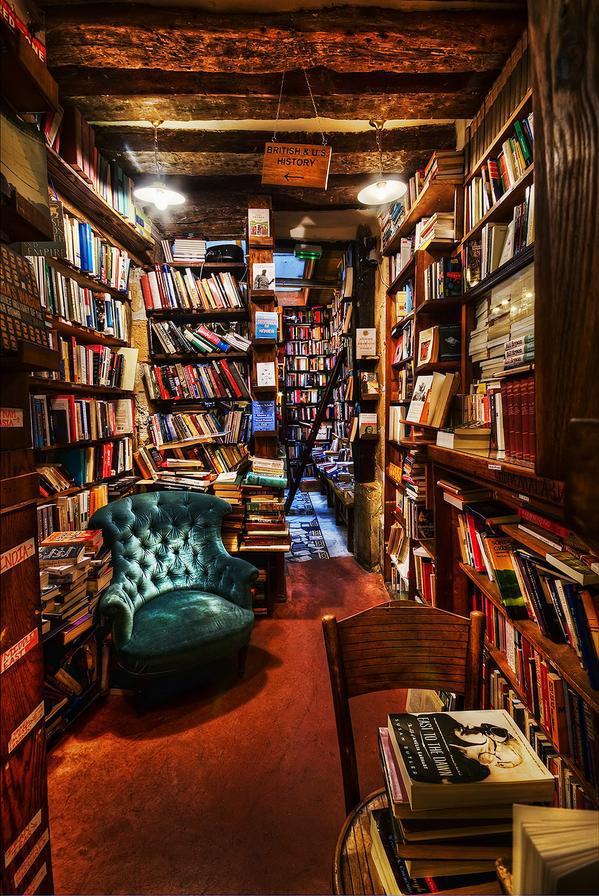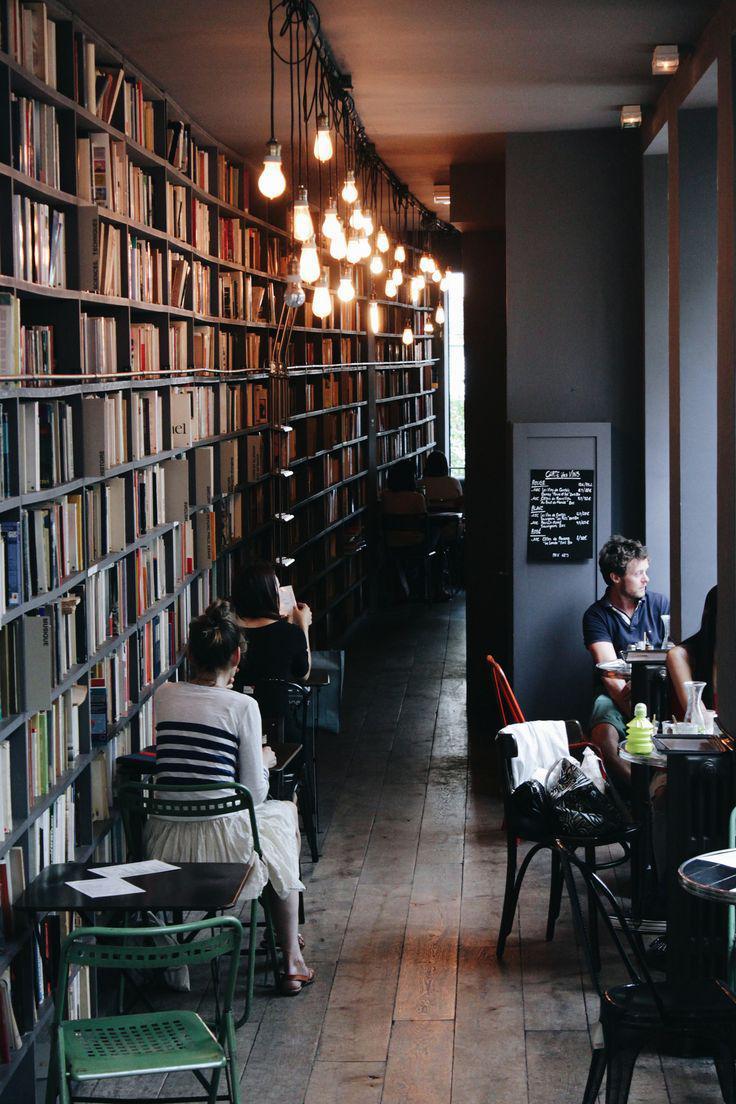The first image is the image on the left, the second image is the image on the right. Assess this claim about the two images: "A booklined reading area includes a tufted wingback chair.". Correct or not? Answer yes or no. Yes. 